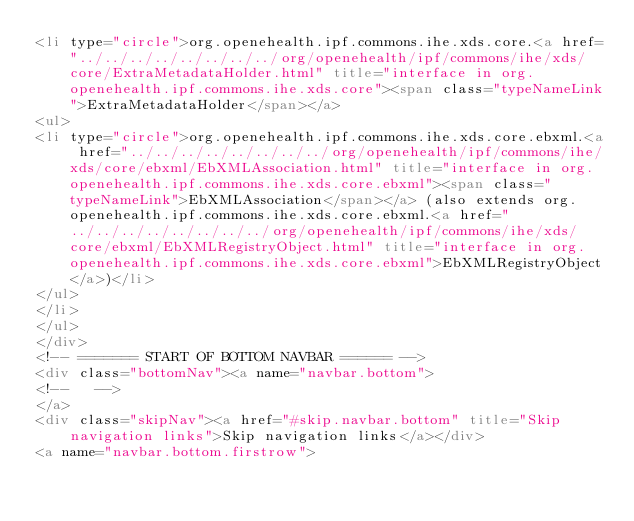Convert code to text. <code><loc_0><loc_0><loc_500><loc_500><_HTML_><li type="circle">org.openehealth.ipf.commons.ihe.xds.core.<a href="../../../../../../../../org/openehealth/ipf/commons/ihe/xds/core/ExtraMetadataHolder.html" title="interface in org.openehealth.ipf.commons.ihe.xds.core"><span class="typeNameLink">ExtraMetadataHolder</span></a>
<ul>
<li type="circle">org.openehealth.ipf.commons.ihe.xds.core.ebxml.<a href="../../../../../../../../org/openehealth/ipf/commons/ihe/xds/core/ebxml/EbXMLAssociation.html" title="interface in org.openehealth.ipf.commons.ihe.xds.core.ebxml"><span class="typeNameLink">EbXMLAssociation</span></a> (also extends org.openehealth.ipf.commons.ihe.xds.core.ebxml.<a href="../../../../../../../../org/openehealth/ipf/commons/ihe/xds/core/ebxml/EbXMLRegistryObject.html" title="interface in org.openehealth.ipf.commons.ihe.xds.core.ebxml">EbXMLRegistryObject</a>)</li>
</ul>
</li>
</ul>
</div>
<!-- ======= START OF BOTTOM NAVBAR ====== -->
<div class="bottomNav"><a name="navbar.bottom">
<!--   -->
</a>
<div class="skipNav"><a href="#skip.navbar.bottom" title="Skip navigation links">Skip navigation links</a></div>
<a name="navbar.bottom.firstrow"></code> 